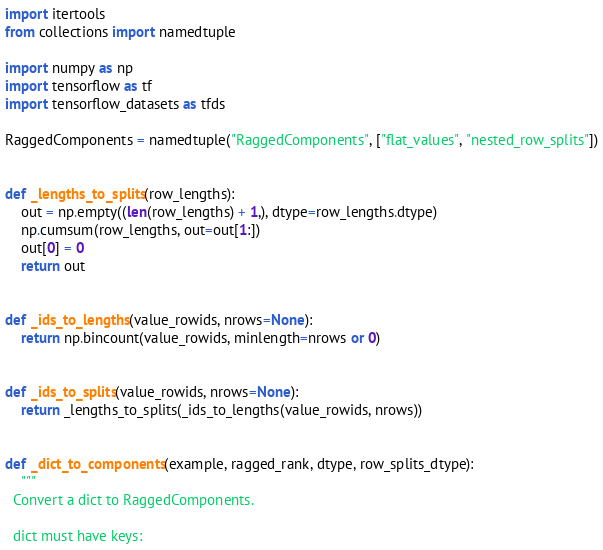<code> <loc_0><loc_0><loc_500><loc_500><_Python_>import itertools
from collections import namedtuple

import numpy as np
import tensorflow as tf
import tensorflow_datasets as tfds

RaggedComponents = namedtuple("RaggedComponents", ["flat_values", "nested_row_splits"])


def _lengths_to_splits(row_lengths):
    out = np.empty((len(row_lengths) + 1,), dtype=row_lengths.dtype)
    np.cumsum(row_lengths, out=out[1:])
    out[0] = 0
    return out


def _ids_to_lengths(value_rowids, nrows=None):
    return np.bincount(value_rowids, minlength=nrows or 0)


def _ids_to_splits(value_rowids, nrows=None):
    return _lengths_to_splits(_ids_to_lengths(value_rowids, nrows))


def _dict_to_components(example, ragged_rank, dtype, row_splits_dtype):
    """
  Convert a dict to RaggedComponents.

  dict must have keys:</code> 